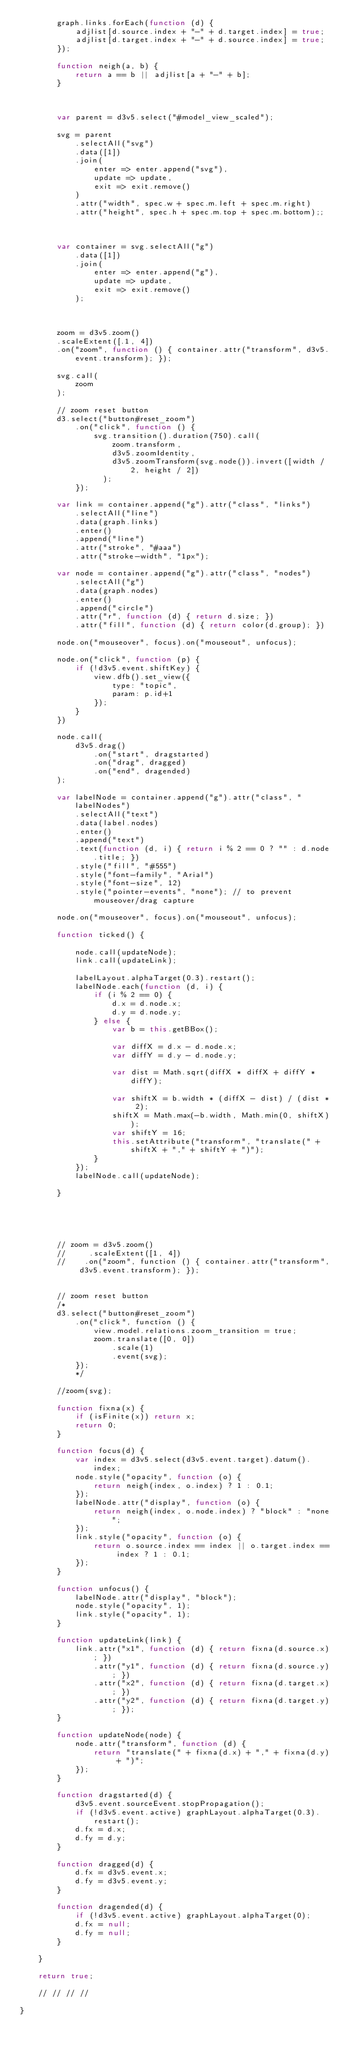Convert code to text. <code><loc_0><loc_0><loc_500><loc_500><_JavaScript_>        graph.links.forEach(function (d) {
            adjlist[d.source.index + "-" + d.target.index] = true;
            adjlist[d.target.index + "-" + d.source.index] = true;
        });

        function neigh(a, b) {
            return a == b || adjlist[a + "-" + b];
        }

  

        var parent = d3v5.select("#model_view_scaled");

        svg = parent
            .selectAll("svg")
            .data([1])
            .join(
                enter => enter.append("svg"),
                update => update,
                exit => exit.remove()
            )
            .attr("width", spec.w + spec.m.left + spec.m.right)
            .attr("height", spec.h + spec.m.top + spec.m.bottom);;



        var container = svg.selectAll("g")
            .data([1])
            .join(
                enter => enter.append("g"),
                update => update,
                exit => exit.remove()
            );



        zoom = d3v5.zoom()
        .scaleExtent([.1, 4])
        .on("zoom", function () { container.attr("transform", d3v5.event.transform); });

        svg.call(
            zoom
        );

        // zoom reset button
        d3.select("button#reset_zoom")
            .on("click", function () {                
                svg.transition().duration(750).call(
                    zoom.transform,
                    d3v5.zoomIdentity,
                    d3v5.zoomTransform(svg.node()).invert([width / 2, height / 2])
                  );
            });

        var link = container.append("g").attr("class", "links")
            .selectAll("line")
            .data(graph.links)
            .enter()
            .append("line")
            .attr("stroke", "#aaa")
            .attr("stroke-width", "1px");

        var node = container.append("g").attr("class", "nodes")
            .selectAll("g")
            .data(graph.nodes)
            .enter()
            .append("circle")
            .attr("r", function (d) { return d.size; })
            .attr("fill", function (d) { return color(d.group); })

        node.on("mouseover", focus).on("mouseout", unfocus);

        node.on("click", function (p) {
            if (!d3v5.event.shiftKey) {
                view.dfb().set_view({
                    type: "topic",
                    param: p.id+1
                });
            }
        })

        node.call(
            d3v5.drag()
                .on("start", dragstarted)
                .on("drag", dragged)
                .on("end", dragended)
        );

        var labelNode = container.append("g").attr("class", "labelNodes")
            .selectAll("text")
            .data(label.nodes)
            .enter()
            .append("text")
            .text(function (d, i) { return i % 2 == 0 ? "" : d.node.title; })
            .style("fill", "#555")
            .style("font-family", "Arial")
            .style("font-size", 12)
            .style("pointer-events", "none"); // to prevent mouseover/drag capture

        node.on("mouseover", focus).on("mouseout", unfocus);

        function ticked() {

            node.call(updateNode);
            link.call(updateLink);

            labelLayout.alphaTarget(0.3).restart();
            labelNode.each(function (d, i) {
                if (i % 2 == 0) {
                    d.x = d.node.x;
                    d.y = d.node.y;
                } else {
                    var b = this.getBBox();

                    var diffX = d.x - d.node.x;
                    var diffY = d.y - d.node.y;

                    var dist = Math.sqrt(diffX * diffX + diffY * diffY);

                    var shiftX = b.width * (diffX - dist) / (dist * 2);
                    shiftX = Math.max(-b.width, Math.min(0, shiftX));
                    var shiftY = 16;
                    this.setAttribute("transform", "translate(" + shiftX + "," + shiftY + ")");
                }
            });
            labelNode.call(updateNode);

        }





        // zoom = d3v5.zoom()
        //     .scaleExtent([1, 4])
        //    .on("zoom", function () { container.attr("transform", d3v5.event.transform); });


        // zoom reset button
        /*
        d3.select("button#reset_zoom")
            .on("click", function () {
                view.model.relations.zoom_transition = true;
                zoom.translate([0, 0])
                    .scale(1)
                    .event(svg);
            });
            */

        //zoom(svg);

        function fixna(x) {
            if (isFinite(x)) return x;
            return 0;
        }

        function focus(d) {
            var index = d3v5.select(d3v5.event.target).datum().index;
            node.style("opacity", function (o) {
                return neigh(index, o.index) ? 1 : 0.1;
            });
            labelNode.attr("display", function (o) {
                return neigh(index, o.node.index) ? "block" : "none";
            });
            link.style("opacity", function (o) {
                return o.source.index == index || o.target.index == index ? 1 : 0.1;
            });
        }

        function unfocus() {
            labelNode.attr("display", "block");
            node.style("opacity", 1);
            link.style("opacity", 1);
        }

        function updateLink(link) {
            link.attr("x1", function (d) { return fixna(d.source.x); })
                .attr("y1", function (d) { return fixna(d.source.y); })
                .attr("x2", function (d) { return fixna(d.target.x); })
                .attr("y2", function (d) { return fixna(d.target.y); });
        }

        function updateNode(node) {
            node.attr("transform", function (d) {
                return "translate(" + fixna(d.x) + "," + fixna(d.y) + ")";
            });
        }

        function dragstarted(d) {
            d3v5.event.sourceEvent.stopPropagation();
            if (!d3v5.event.active) graphLayout.alphaTarget(0.3).restart();
            d.fx = d.x;
            d.fy = d.y;
        }

        function dragged(d) {
            d.fx = d3v5.event.x;
            d.fy = d3v5.event.y;
        }

        function dragended(d) {
            if (!d3v5.event.active) graphLayout.alphaTarget(0);
            d.fx = null;
            d.fy = null;
        }

    }

    return true;

    // // // // 

}</code> 